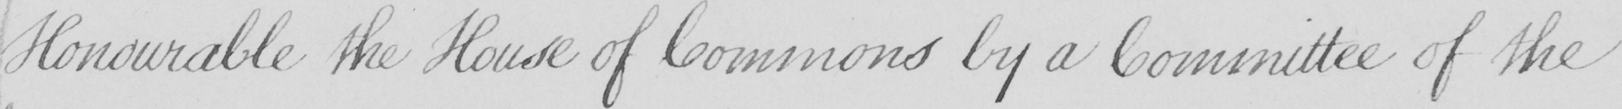What does this handwritten line say? Honourable the House of Commons by a Committee of the 